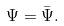<formula> <loc_0><loc_0><loc_500><loc_500>\Psi = \bar { \Psi } .</formula> 